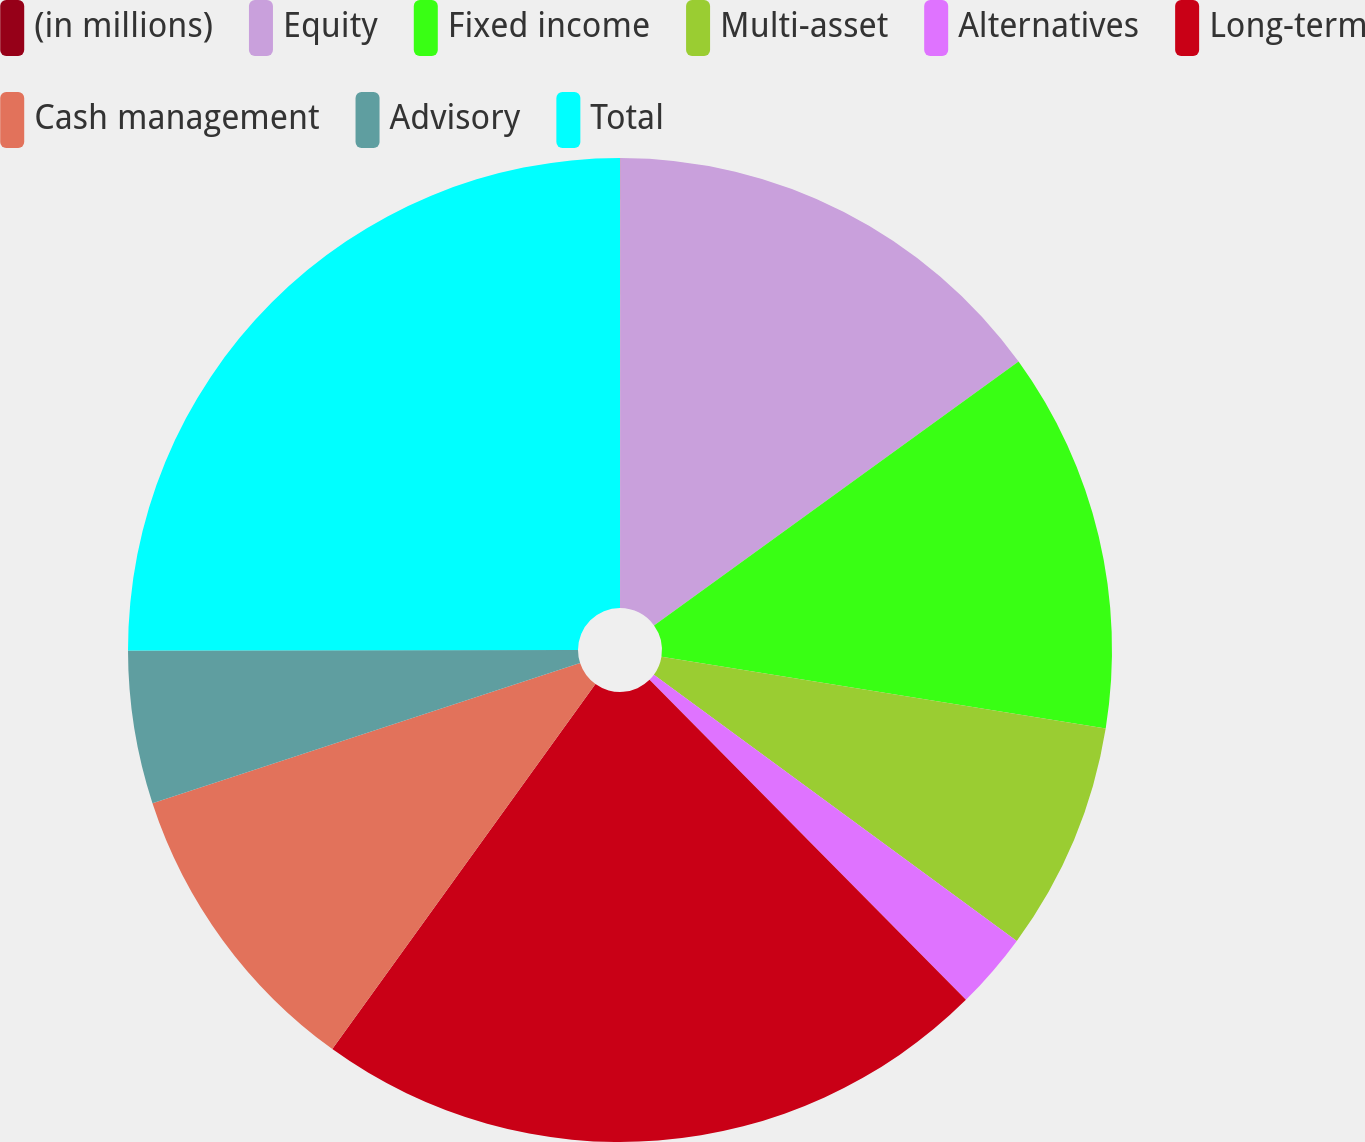Convert chart. <chart><loc_0><loc_0><loc_500><loc_500><pie_chart><fcel>(in millions)<fcel>Equity<fcel>Fixed income<fcel>Multi-asset<fcel>Alternatives<fcel>Long-term<fcel>Cash management<fcel>Advisory<fcel>Total<nl><fcel>0.01%<fcel>15.02%<fcel>12.52%<fcel>7.52%<fcel>2.52%<fcel>22.35%<fcel>10.02%<fcel>5.02%<fcel>25.02%<nl></chart> 